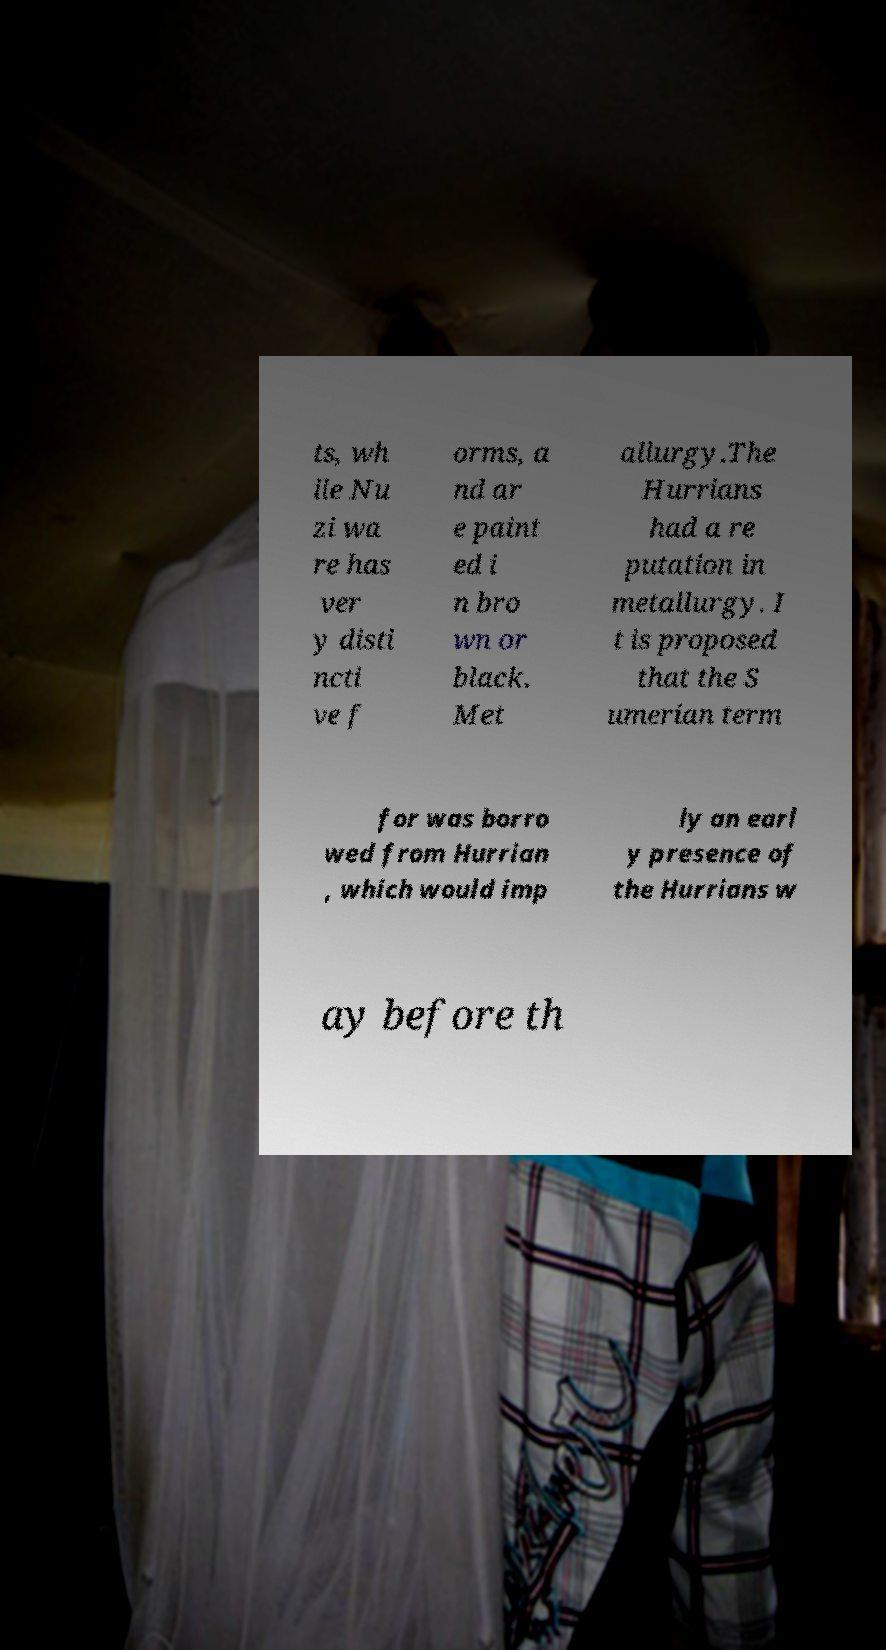Please read and relay the text visible in this image. What does it say? ts, wh ile Nu zi wa re has ver y disti ncti ve f orms, a nd ar e paint ed i n bro wn or black. Met allurgy.The Hurrians had a re putation in metallurgy. I t is proposed that the S umerian term for was borro wed from Hurrian , which would imp ly an earl y presence of the Hurrians w ay before th 